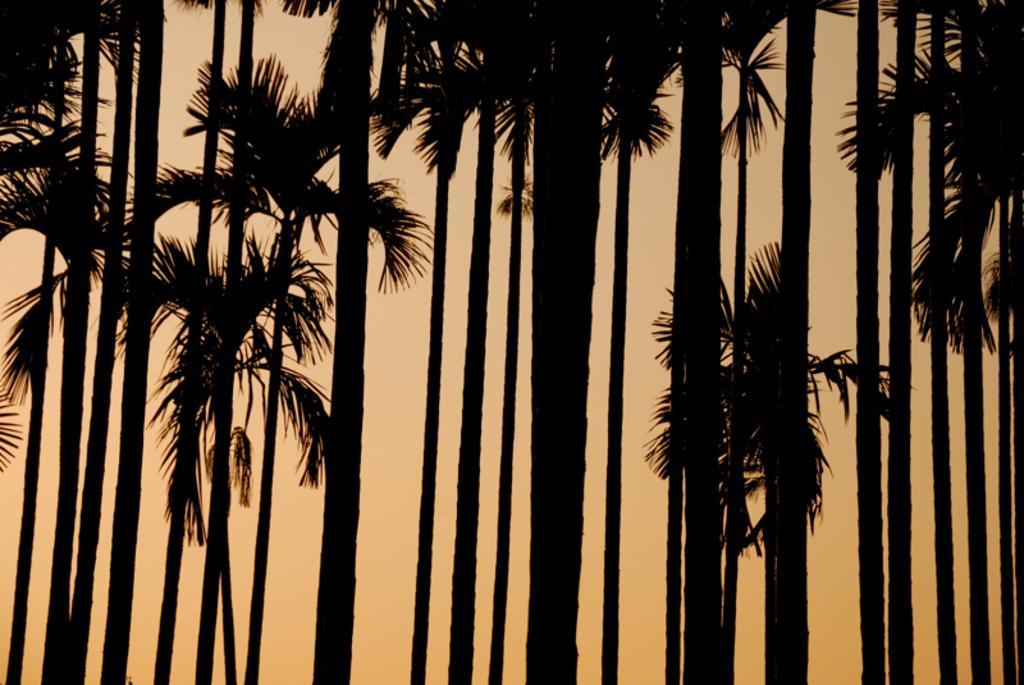Please provide a concise description of this image. In the picture there are many trees present, there is a sunset present. 